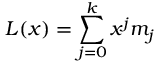<formula> <loc_0><loc_0><loc_500><loc_500>L ( x ) = \sum _ { j = 0 } ^ { k } x ^ { j } m _ { j }</formula> 